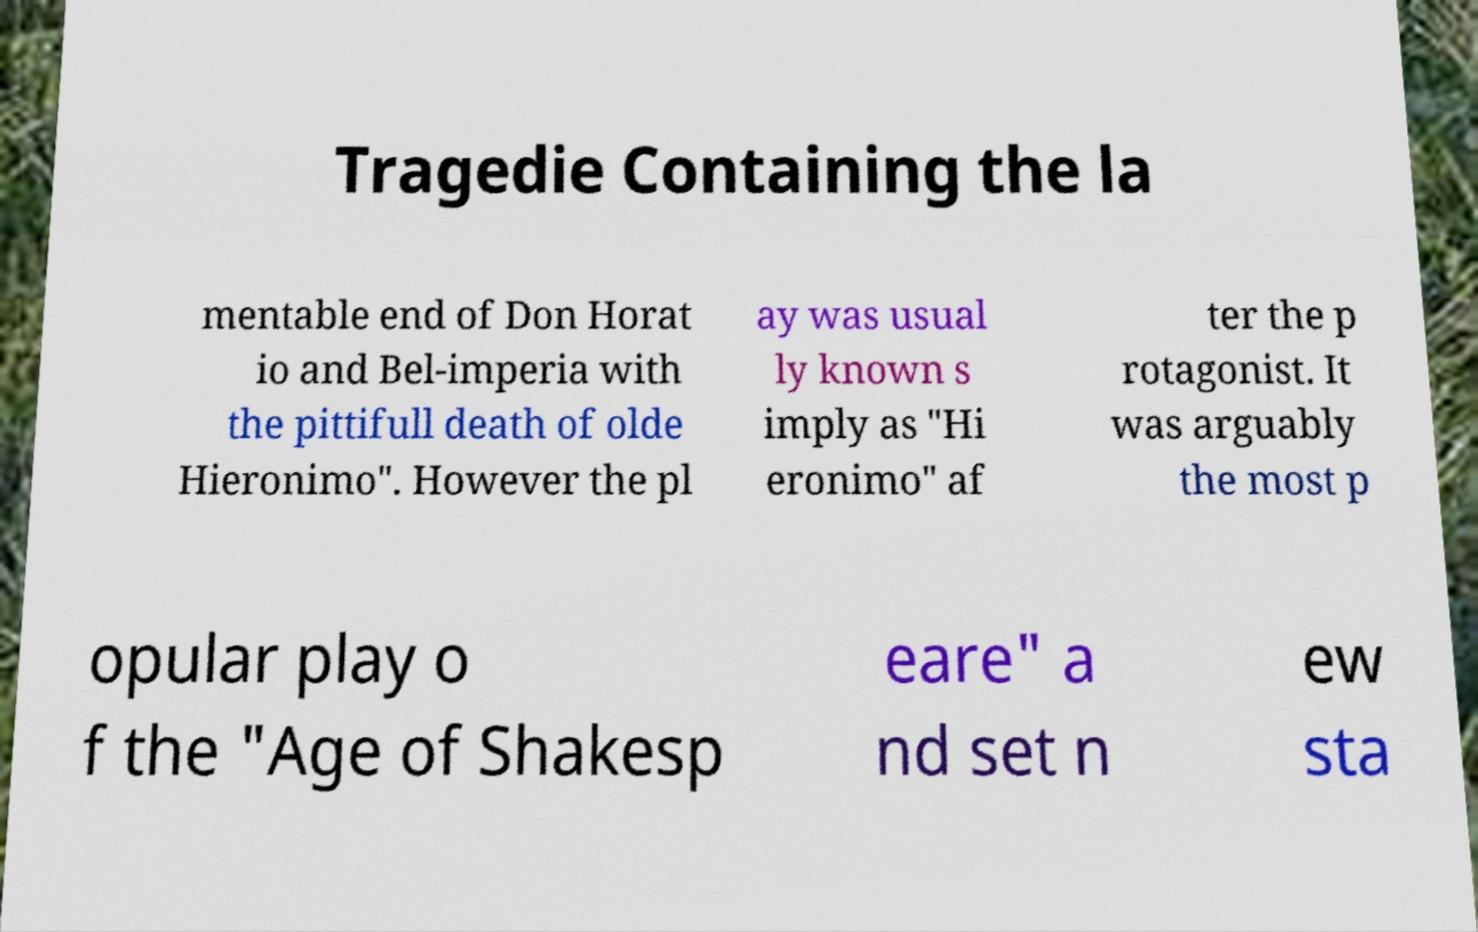Could you extract and type out the text from this image? Tragedie Containing the la mentable end of Don Horat io and Bel-imperia with the pittifull death of olde Hieronimo". However the pl ay was usual ly known s imply as "Hi eronimo" af ter the p rotagonist. It was arguably the most p opular play o f the "Age of Shakesp eare" a nd set n ew sta 